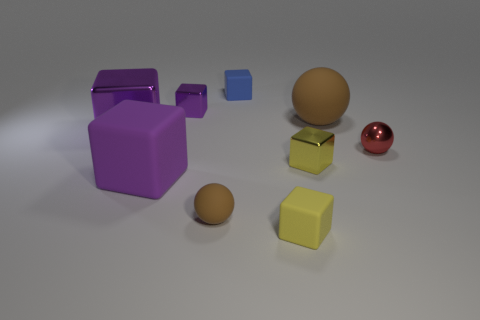Can you describe the arrangement of shapes and their colors? The image presents a collection of various shapes arranged without any apparent pattern on a flat surface. Starting from the left, there's a large purple cube with a slightly opened drawer, a medium-sized blue cube floating above the ground, a large brown sphere, a tiny brown sphere, a small gold cube, a medium-sized yellow cube, and a small shiny red sphere. 